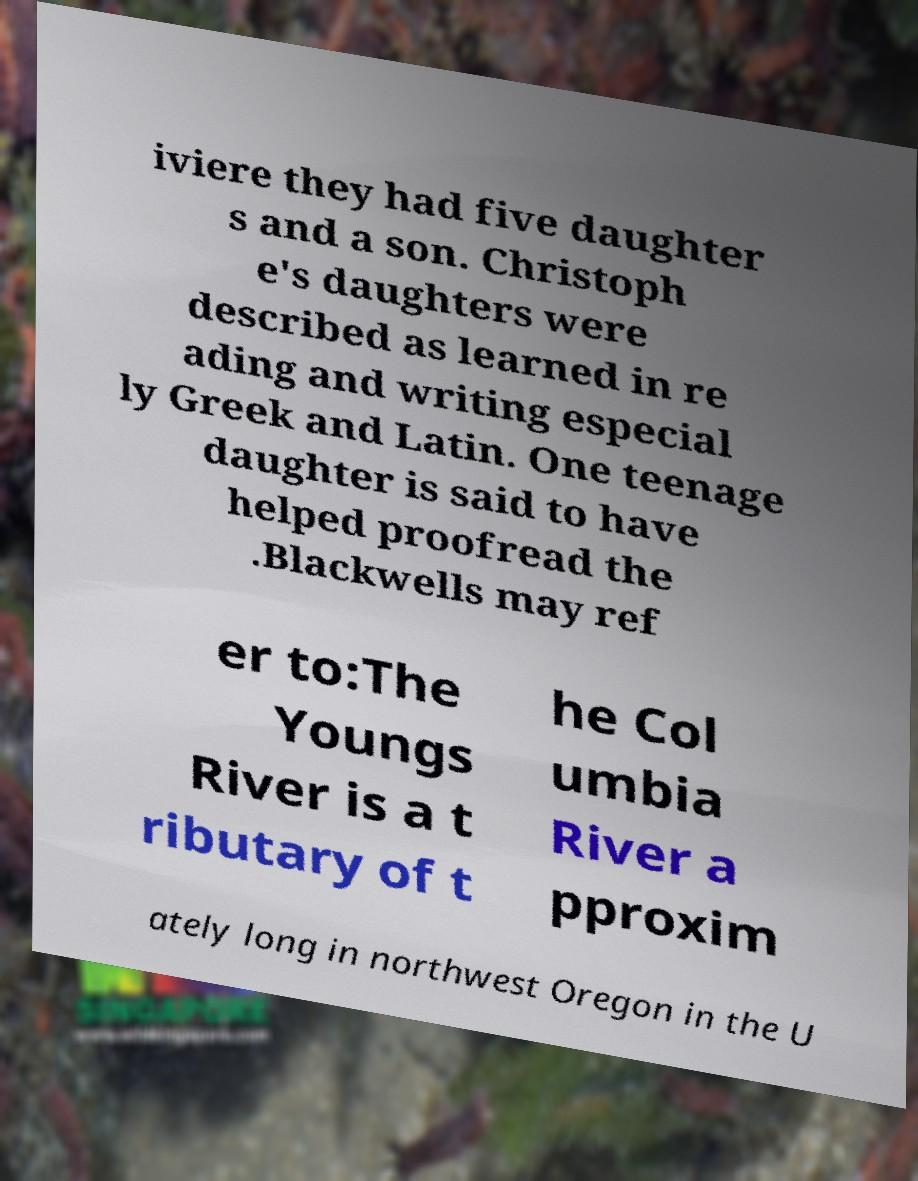There's text embedded in this image that I need extracted. Can you transcribe it verbatim? iviere they had five daughter s and a son. Christoph e's daughters were described as learned in re ading and writing especial ly Greek and Latin. One teenage daughter is said to have helped proofread the .Blackwells may ref er to:The Youngs River is a t ributary of t he Col umbia River a pproxim ately long in northwest Oregon in the U 